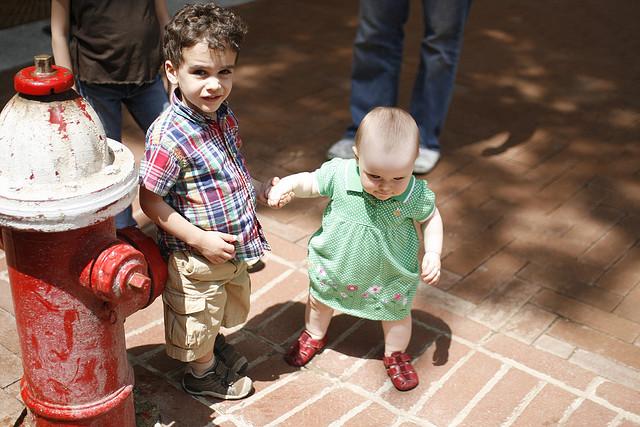Do these children look well taken care of?
Answer briefly. Yes. What color are the girl's shoes?
Write a very short answer. Red. Is the girl older than the boy?
Quick response, please. No. 